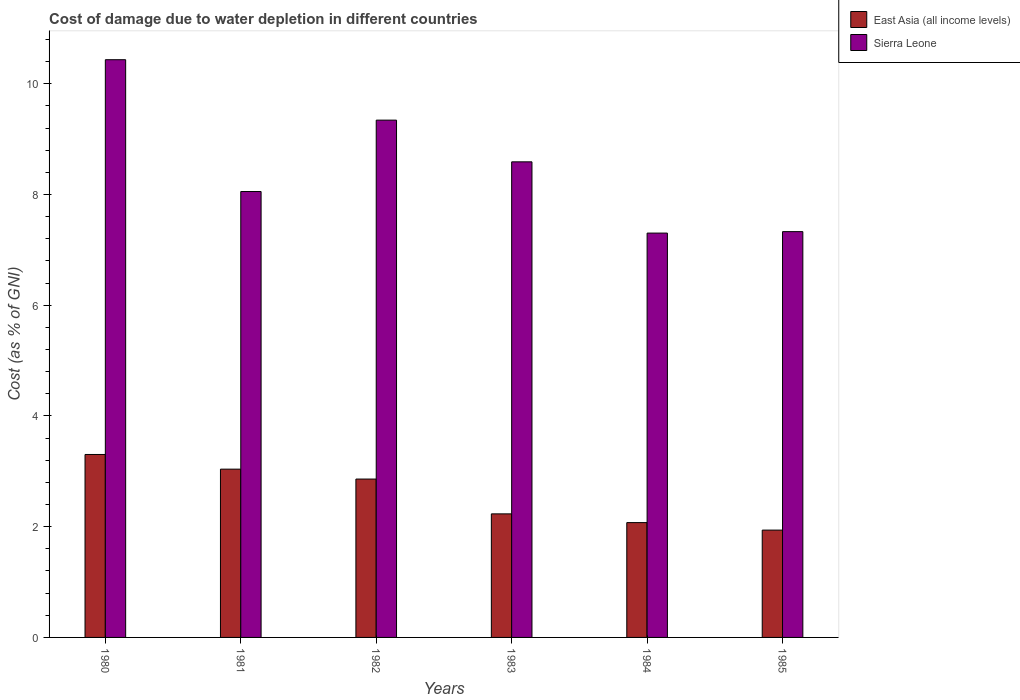How many groups of bars are there?
Your answer should be compact. 6. Are the number of bars per tick equal to the number of legend labels?
Offer a terse response. Yes. How many bars are there on the 6th tick from the left?
Ensure brevity in your answer.  2. In how many cases, is the number of bars for a given year not equal to the number of legend labels?
Your response must be concise. 0. What is the cost of damage caused due to water depletion in Sierra Leone in 1982?
Make the answer very short. 9.34. Across all years, what is the maximum cost of damage caused due to water depletion in East Asia (all income levels)?
Your answer should be very brief. 3.3. Across all years, what is the minimum cost of damage caused due to water depletion in East Asia (all income levels)?
Your answer should be compact. 1.94. In which year was the cost of damage caused due to water depletion in Sierra Leone maximum?
Your answer should be compact. 1980. What is the total cost of damage caused due to water depletion in Sierra Leone in the graph?
Your response must be concise. 51.05. What is the difference between the cost of damage caused due to water depletion in East Asia (all income levels) in 1983 and that in 1985?
Keep it short and to the point. 0.29. What is the difference between the cost of damage caused due to water depletion in East Asia (all income levels) in 1981 and the cost of damage caused due to water depletion in Sierra Leone in 1985?
Keep it short and to the point. -4.29. What is the average cost of damage caused due to water depletion in Sierra Leone per year?
Ensure brevity in your answer.  8.51. In the year 1980, what is the difference between the cost of damage caused due to water depletion in East Asia (all income levels) and cost of damage caused due to water depletion in Sierra Leone?
Give a very brief answer. -7.13. In how many years, is the cost of damage caused due to water depletion in East Asia (all income levels) greater than 7.6 %?
Provide a short and direct response. 0. What is the ratio of the cost of damage caused due to water depletion in East Asia (all income levels) in 1980 to that in 1981?
Give a very brief answer. 1.09. Is the cost of damage caused due to water depletion in East Asia (all income levels) in 1980 less than that in 1984?
Your answer should be very brief. No. What is the difference between the highest and the second highest cost of damage caused due to water depletion in East Asia (all income levels)?
Keep it short and to the point. 0.26. What is the difference between the highest and the lowest cost of damage caused due to water depletion in Sierra Leone?
Offer a terse response. 3.13. What does the 1st bar from the left in 1982 represents?
Offer a terse response. East Asia (all income levels). What does the 1st bar from the right in 1981 represents?
Provide a succinct answer. Sierra Leone. Are all the bars in the graph horizontal?
Your answer should be compact. No. Are the values on the major ticks of Y-axis written in scientific E-notation?
Provide a succinct answer. No. Where does the legend appear in the graph?
Your answer should be very brief. Top right. What is the title of the graph?
Your answer should be very brief. Cost of damage due to water depletion in different countries. What is the label or title of the X-axis?
Your response must be concise. Years. What is the label or title of the Y-axis?
Make the answer very short. Cost (as % of GNI). What is the Cost (as % of GNI) of East Asia (all income levels) in 1980?
Provide a succinct answer. 3.3. What is the Cost (as % of GNI) of Sierra Leone in 1980?
Offer a very short reply. 10.43. What is the Cost (as % of GNI) of East Asia (all income levels) in 1981?
Offer a terse response. 3.04. What is the Cost (as % of GNI) in Sierra Leone in 1981?
Offer a terse response. 8.05. What is the Cost (as % of GNI) in East Asia (all income levels) in 1982?
Your response must be concise. 2.86. What is the Cost (as % of GNI) in Sierra Leone in 1982?
Offer a terse response. 9.34. What is the Cost (as % of GNI) in East Asia (all income levels) in 1983?
Your answer should be very brief. 2.23. What is the Cost (as % of GNI) of Sierra Leone in 1983?
Offer a very short reply. 8.59. What is the Cost (as % of GNI) in East Asia (all income levels) in 1984?
Your answer should be compact. 2.07. What is the Cost (as % of GNI) in Sierra Leone in 1984?
Provide a succinct answer. 7.3. What is the Cost (as % of GNI) in East Asia (all income levels) in 1985?
Provide a short and direct response. 1.94. What is the Cost (as % of GNI) in Sierra Leone in 1985?
Your answer should be very brief. 7.33. Across all years, what is the maximum Cost (as % of GNI) of East Asia (all income levels)?
Offer a very short reply. 3.3. Across all years, what is the maximum Cost (as % of GNI) in Sierra Leone?
Keep it short and to the point. 10.43. Across all years, what is the minimum Cost (as % of GNI) of East Asia (all income levels)?
Give a very brief answer. 1.94. Across all years, what is the minimum Cost (as % of GNI) of Sierra Leone?
Give a very brief answer. 7.3. What is the total Cost (as % of GNI) in East Asia (all income levels) in the graph?
Make the answer very short. 15.45. What is the total Cost (as % of GNI) in Sierra Leone in the graph?
Your answer should be compact. 51.05. What is the difference between the Cost (as % of GNI) of East Asia (all income levels) in 1980 and that in 1981?
Provide a succinct answer. 0.26. What is the difference between the Cost (as % of GNI) of Sierra Leone in 1980 and that in 1981?
Provide a short and direct response. 2.38. What is the difference between the Cost (as % of GNI) of East Asia (all income levels) in 1980 and that in 1982?
Your answer should be compact. 0.44. What is the difference between the Cost (as % of GNI) in Sierra Leone in 1980 and that in 1982?
Ensure brevity in your answer.  1.09. What is the difference between the Cost (as % of GNI) of East Asia (all income levels) in 1980 and that in 1983?
Give a very brief answer. 1.07. What is the difference between the Cost (as % of GNI) in Sierra Leone in 1980 and that in 1983?
Offer a terse response. 1.84. What is the difference between the Cost (as % of GNI) of East Asia (all income levels) in 1980 and that in 1984?
Provide a short and direct response. 1.23. What is the difference between the Cost (as % of GNI) of Sierra Leone in 1980 and that in 1984?
Keep it short and to the point. 3.13. What is the difference between the Cost (as % of GNI) of East Asia (all income levels) in 1980 and that in 1985?
Offer a terse response. 1.37. What is the difference between the Cost (as % of GNI) of Sierra Leone in 1980 and that in 1985?
Make the answer very short. 3.1. What is the difference between the Cost (as % of GNI) in East Asia (all income levels) in 1981 and that in 1982?
Give a very brief answer. 0.18. What is the difference between the Cost (as % of GNI) of Sierra Leone in 1981 and that in 1982?
Provide a short and direct response. -1.29. What is the difference between the Cost (as % of GNI) of East Asia (all income levels) in 1981 and that in 1983?
Provide a short and direct response. 0.81. What is the difference between the Cost (as % of GNI) of Sierra Leone in 1981 and that in 1983?
Make the answer very short. -0.54. What is the difference between the Cost (as % of GNI) in East Asia (all income levels) in 1981 and that in 1984?
Provide a short and direct response. 0.97. What is the difference between the Cost (as % of GNI) of Sierra Leone in 1981 and that in 1984?
Keep it short and to the point. 0.75. What is the difference between the Cost (as % of GNI) of East Asia (all income levels) in 1981 and that in 1985?
Ensure brevity in your answer.  1.1. What is the difference between the Cost (as % of GNI) in Sierra Leone in 1981 and that in 1985?
Your answer should be compact. 0.72. What is the difference between the Cost (as % of GNI) of East Asia (all income levels) in 1982 and that in 1983?
Your answer should be very brief. 0.63. What is the difference between the Cost (as % of GNI) in Sierra Leone in 1982 and that in 1983?
Your response must be concise. 0.75. What is the difference between the Cost (as % of GNI) of East Asia (all income levels) in 1982 and that in 1984?
Your response must be concise. 0.79. What is the difference between the Cost (as % of GNI) of Sierra Leone in 1982 and that in 1984?
Keep it short and to the point. 2.04. What is the difference between the Cost (as % of GNI) in East Asia (all income levels) in 1982 and that in 1985?
Ensure brevity in your answer.  0.92. What is the difference between the Cost (as % of GNI) of Sierra Leone in 1982 and that in 1985?
Provide a succinct answer. 2.01. What is the difference between the Cost (as % of GNI) of East Asia (all income levels) in 1983 and that in 1984?
Give a very brief answer. 0.16. What is the difference between the Cost (as % of GNI) in Sierra Leone in 1983 and that in 1984?
Offer a very short reply. 1.29. What is the difference between the Cost (as % of GNI) in East Asia (all income levels) in 1983 and that in 1985?
Give a very brief answer. 0.29. What is the difference between the Cost (as % of GNI) of Sierra Leone in 1983 and that in 1985?
Provide a succinct answer. 1.26. What is the difference between the Cost (as % of GNI) in East Asia (all income levels) in 1984 and that in 1985?
Offer a terse response. 0.14. What is the difference between the Cost (as % of GNI) in Sierra Leone in 1984 and that in 1985?
Provide a succinct answer. -0.03. What is the difference between the Cost (as % of GNI) in East Asia (all income levels) in 1980 and the Cost (as % of GNI) in Sierra Leone in 1981?
Your response must be concise. -4.75. What is the difference between the Cost (as % of GNI) in East Asia (all income levels) in 1980 and the Cost (as % of GNI) in Sierra Leone in 1982?
Give a very brief answer. -6.04. What is the difference between the Cost (as % of GNI) in East Asia (all income levels) in 1980 and the Cost (as % of GNI) in Sierra Leone in 1983?
Keep it short and to the point. -5.29. What is the difference between the Cost (as % of GNI) in East Asia (all income levels) in 1980 and the Cost (as % of GNI) in Sierra Leone in 1984?
Your answer should be compact. -4. What is the difference between the Cost (as % of GNI) of East Asia (all income levels) in 1980 and the Cost (as % of GNI) of Sierra Leone in 1985?
Provide a succinct answer. -4.03. What is the difference between the Cost (as % of GNI) in East Asia (all income levels) in 1981 and the Cost (as % of GNI) in Sierra Leone in 1982?
Give a very brief answer. -6.3. What is the difference between the Cost (as % of GNI) in East Asia (all income levels) in 1981 and the Cost (as % of GNI) in Sierra Leone in 1983?
Give a very brief answer. -5.55. What is the difference between the Cost (as % of GNI) in East Asia (all income levels) in 1981 and the Cost (as % of GNI) in Sierra Leone in 1984?
Provide a succinct answer. -4.26. What is the difference between the Cost (as % of GNI) of East Asia (all income levels) in 1981 and the Cost (as % of GNI) of Sierra Leone in 1985?
Offer a terse response. -4.29. What is the difference between the Cost (as % of GNI) in East Asia (all income levels) in 1982 and the Cost (as % of GNI) in Sierra Leone in 1983?
Make the answer very short. -5.73. What is the difference between the Cost (as % of GNI) in East Asia (all income levels) in 1982 and the Cost (as % of GNI) in Sierra Leone in 1984?
Ensure brevity in your answer.  -4.44. What is the difference between the Cost (as % of GNI) of East Asia (all income levels) in 1982 and the Cost (as % of GNI) of Sierra Leone in 1985?
Your answer should be very brief. -4.47. What is the difference between the Cost (as % of GNI) in East Asia (all income levels) in 1983 and the Cost (as % of GNI) in Sierra Leone in 1984?
Give a very brief answer. -5.07. What is the difference between the Cost (as % of GNI) of East Asia (all income levels) in 1983 and the Cost (as % of GNI) of Sierra Leone in 1985?
Ensure brevity in your answer.  -5.1. What is the difference between the Cost (as % of GNI) in East Asia (all income levels) in 1984 and the Cost (as % of GNI) in Sierra Leone in 1985?
Ensure brevity in your answer.  -5.26. What is the average Cost (as % of GNI) of East Asia (all income levels) per year?
Your answer should be very brief. 2.57. What is the average Cost (as % of GNI) in Sierra Leone per year?
Provide a short and direct response. 8.51. In the year 1980, what is the difference between the Cost (as % of GNI) in East Asia (all income levels) and Cost (as % of GNI) in Sierra Leone?
Your response must be concise. -7.13. In the year 1981, what is the difference between the Cost (as % of GNI) of East Asia (all income levels) and Cost (as % of GNI) of Sierra Leone?
Offer a very short reply. -5.01. In the year 1982, what is the difference between the Cost (as % of GNI) of East Asia (all income levels) and Cost (as % of GNI) of Sierra Leone?
Keep it short and to the point. -6.48. In the year 1983, what is the difference between the Cost (as % of GNI) in East Asia (all income levels) and Cost (as % of GNI) in Sierra Leone?
Offer a terse response. -6.36. In the year 1984, what is the difference between the Cost (as % of GNI) in East Asia (all income levels) and Cost (as % of GNI) in Sierra Leone?
Your response must be concise. -5.23. In the year 1985, what is the difference between the Cost (as % of GNI) in East Asia (all income levels) and Cost (as % of GNI) in Sierra Leone?
Keep it short and to the point. -5.39. What is the ratio of the Cost (as % of GNI) of East Asia (all income levels) in 1980 to that in 1981?
Give a very brief answer. 1.09. What is the ratio of the Cost (as % of GNI) in Sierra Leone in 1980 to that in 1981?
Make the answer very short. 1.3. What is the ratio of the Cost (as % of GNI) of East Asia (all income levels) in 1980 to that in 1982?
Your answer should be compact. 1.16. What is the ratio of the Cost (as % of GNI) of Sierra Leone in 1980 to that in 1982?
Give a very brief answer. 1.12. What is the ratio of the Cost (as % of GNI) in East Asia (all income levels) in 1980 to that in 1983?
Keep it short and to the point. 1.48. What is the ratio of the Cost (as % of GNI) of Sierra Leone in 1980 to that in 1983?
Offer a very short reply. 1.21. What is the ratio of the Cost (as % of GNI) in East Asia (all income levels) in 1980 to that in 1984?
Your answer should be very brief. 1.59. What is the ratio of the Cost (as % of GNI) of Sierra Leone in 1980 to that in 1984?
Ensure brevity in your answer.  1.43. What is the ratio of the Cost (as % of GNI) in East Asia (all income levels) in 1980 to that in 1985?
Your answer should be very brief. 1.7. What is the ratio of the Cost (as % of GNI) in Sierra Leone in 1980 to that in 1985?
Provide a short and direct response. 1.42. What is the ratio of the Cost (as % of GNI) of Sierra Leone in 1981 to that in 1982?
Keep it short and to the point. 0.86. What is the ratio of the Cost (as % of GNI) in East Asia (all income levels) in 1981 to that in 1983?
Your response must be concise. 1.36. What is the ratio of the Cost (as % of GNI) in Sierra Leone in 1981 to that in 1983?
Offer a terse response. 0.94. What is the ratio of the Cost (as % of GNI) of East Asia (all income levels) in 1981 to that in 1984?
Your answer should be very brief. 1.47. What is the ratio of the Cost (as % of GNI) in Sierra Leone in 1981 to that in 1984?
Your response must be concise. 1.1. What is the ratio of the Cost (as % of GNI) of East Asia (all income levels) in 1981 to that in 1985?
Your answer should be compact. 1.57. What is the ratio of the Cost (as % of GNI) in Sierra Leone in 1981 to that in 1985?
Your answer should be very brief. 1.1. What is the ratio of the Cost (as % of GNI) of East Asia (all income levels) in 1982 to that in 1983?
Your answer should be compact. 1.28. What is the ratio of the Cost (as % of GNI) in Sierra Leone in 1982 to that in 1983?
Make the answer very short. 1.09. What is the ratio of the Cost (as % of GNI) of East Asia (all income levels) in 1982 to that in 1984?
Keep it short and to the point. 1.38. What is the ratio of the Cost (as % of GNI) in Sierra Leone in 1982 to that in 1984?
Offer a terse response. 1.28. What is the ratio of the Cost (as % of GNI) of East Asia (all income levels) in 1982 to that in 1985?
Offer a very short reply. 1.48. What is the ratio of the Cost (as % of GNI) of Sierra Leone in 1982 to that in 1985?
Keep it short and to the point. 1.27. What is the ratio of the Cost (as % of GNI) in East Asia (all income levels) in 1983 to that in 1984?
Provide a short and direct response. 1.08. What is the ratio of the Cost (as % of GNI) in Sierra Leone in 1983 to that in 1984?
Keep it short and to the point. 1.18. What is the ratio of the Cost (as % of GNI) of East Asia (all income levels) in 1983 to that in 1985?
Your answer should be compact. 1.15. What is the ratio of the Cost (as % of GNI) in Sierra Leone in 1983 to that in 1985?
Your answer should be very brief. 1.17. What is the ratio of the Cost (as % of GNI) in East Asia (all income levels) in 1984 to that in 1985?
Offer a very short reply. 1.07. What is the difference between the highest and the second highest Cost (as % of GNI) in East Asia (all income levels)?
Give a very brief answer. 0.26. What is the difference between the highest and the second highest Cost (as % of GNI) of Sierra Leone?
Offer a very short reply. 1.09. What is the difference between the highest and the lowest Cost (as % of GNI) of East Asia (all income levels)?
Your response must be concise. 1.37. What is the difference between the highest and the lowest Cost (as % of GNI) of Sierra Leone?
Keep it short and to the point. 3.13. 